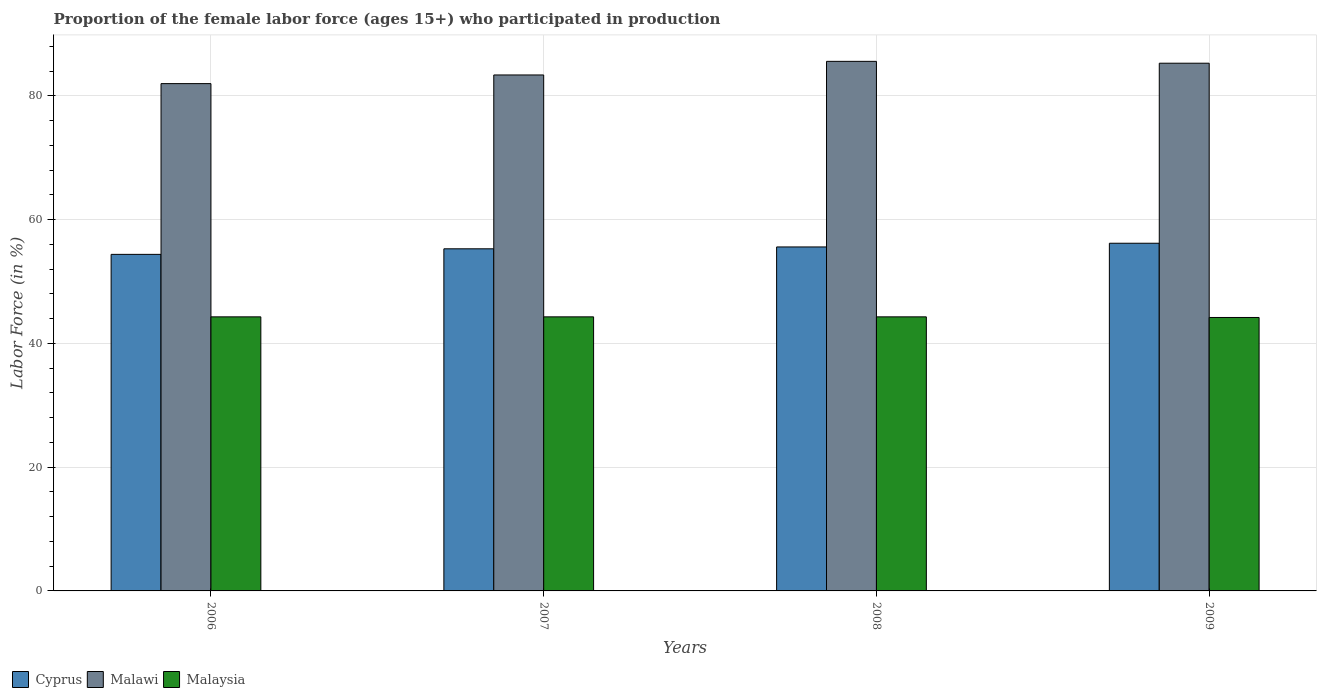How many different coloured bars are there?
Your answer should be very brief. 3. How many bars are there on the 1st tick from the right?
Offer a terse response. 3. In how many cases, is the number of bars for a given year not equal to the number of legend labels?
Keep it short and to the point. 0. What is the proportion of the female labor force who participated in production in Malawi in 2006?
Your answer should be very brief. 82. Across all years, what is the maximum proportion of the female labor force who participated in production in Malaysia?
Offer a very short reply. 44.3. In which year was the proportion of the female labor force who participated in production in Cyprus maximum?
Offer a very short reply. 2009. What is the total proportion of the female labor force who participated in production in Malawi in the graph?
Provide a short and direct response. 336.3. What is the difference between the proportion of the female labor force who participated in production in Malawi in 2006 and that in 2008?
Offer a very short reply. -3.6. What is the difference between the proportion of the female labor force who participated in production in Malaysia in 2008 and the proportion of the female labor force who participated in production in Cyprus in 2006?
Ensure brevity in your answer.  -10.1. What is the average proportion of the female labor force who participated in production in Malaysia per year?
Offer a very short reply. 44.27. In the year 2007, what is the difference between the proportion of the female labor force who participated in production in Malaysia and proportion of the female labor force who participated in production in Malawi?
Offer a terse response. -39.1. In how many years, is the proportion of the female labor force who participated in production in Cyprus greater than 68 %?
Offer a very short reply. 0. What is the ratio of the proportion of the female labor force who participated in production in Malawi in 2007 to that in 2009?
Ensure brevity in your answer.  0.98. Is the difference between the proportion of the female labor force who participated in production in Malaysia in 2008 and 2009 greater than the difference between the proportion of the female labor force who participated in production in Malawi in 2008 and 2009?
Ensure brevity in your answer.  No. What is the difference between the highest and the lowest proportion of the female labor force who participated in production in Malaysia?
Your answer should be very brief. 0.1. In how many years, is the proportion of the female labor force who participated in production in Cyprus greater than the average proportion of the female labor force who participated in production in Cyprus taken over all years?
Provide a short and direct response. 2. What does the 3rd bar from the left in 2009 represents?
Ensure brevity in your answer.  Malaysia. What does the 1st bar from the right in 2006 represents?
Keep it short and to the point. Malaysia. What is the difference between two consecutive major ticks on the Y-axis?
Ensure brevity in your answer.  20. Are the values on the major ticks of Y-axis written in scientific E-notation?
Provide a succinct answer. No. Does the graph contain grids?
Provide a succinct answer. Yes. How are the legend labels stacked?
Provide a succinct answer. Horizontal. What is the title of the graph?
Provide a short and direct response. Proportion of the female labor force (ages 15+) who participated in production. Does "Senegal" appear as one of the legend labels in the graph?
Make the answer very short. No. What is the label or title of the Y-axis?
Give a very brief answer. Labor Force (in %). What is the Labor Force (in %) of Cyprus in 2006?
Give a very brief answer. 54.4. What is the Labor Force (in %) of Malawi in 2006?
Make the answer very short. 82. What is the Labor Force (in %) of Malaysia in 2006?
Your answer should be compact. 44.3. What is the Labor Force (in %) of Cyprus in 2007?
Your answer should be very brief. 55.3. What is the Labor Force (in %) of Malawi in 2007?
Make the answer very short. 83.4. What is the Labor Force (in %) in Malaysia in 2007?
Offer a terse response. 44.3. What is the Labor Force (in %) of Cyprus in 2008?
Your answer should be very brief. 55.6. What is the Labor Force (in %) in Malawi in 2008?
Your response must be concise. 85.6. What is the Labor Force (in %) in Malaysia in 2008?
Your answer should be compact. 44.3. What is the Labor Force (in %) in Cyprus in 2009?
Make the answer very short. 56.2. What is the Labor Force (in %) of Malawi in 2009?
Offer a very short reply. 85.3. What is the Labor Force (in %) in Malaysia in 2009?
Your response must be concise. 44.2. Across all years, what is the maximum Labor Force (in %) in Cyprus?
Offer a terse response. 56.2. Across all years, what is the maximum Labor Force (in %) in Malawi?
Provide a short and direct response. 85.6. Across all years, what is the maximum Labor Force (in %) in Malaysia?
Your answer should be very brief. 44.3. Across all years, what is the minimum Labor Force (in %) of Cyprus?
Provide a short and direct response. 54.4. Across all years, what is the minimum Labor Force (in %) of Malawi?
Your answer should be compact. 82. Across all years, what is the minimum Labor Force (in %) in Malaysia?
Provide a succinct answer. 44.2. What is the total Labor Force (in %) of Cyprus in the graph?
Provide a succinct answer. 221.5. What is the total Labor Force (in %) in Malawi in the graph?
Offer a terse response. 336.3. What is the total Labor Force (in %) in Malaysia in the graph?
Your response must be concise. 177.1. What is the difference between the Labor Force (in %) in Cyprus in 2006 and that in 2007?
Offer a very short reply. -0.9. What is the difference between the Labor Force (in %) of Malaysia in 2006 and that in 2007?
Keep it short and to the point. 0. What is the difference between the Labor Force (in %) in Cyprus in 2006 and that in 2008?
Give a very brief answer. -1.2. What is the difference between the Labor Force (in %) in Malawi in 2006 and that in 2008?
Ensure brevity in your answer.  -3.6. What is the difference between the Labor Force (in %) in Malawi in 2006 and that in 2009?
Make the answer very short. -3.3. What is the difference between the Labor Force (in %) in Cyprus in 2008 and that in 2009?
Provide a short and direct response. -0.6. What is the difference between the Labor Force (in %) in Malawi in 2008 and that in 2009?
Your answer should be compact. 0.3. What is the difference between the Labor Force (in %) of Malawi in 2006 and the Labor Force (in %) of Malaysia in 2007?
Keep it short and to the point. 37.7. What is the difference between the Labor Force (in %) in Cyprus in 2006 and the Labor Force (in %) in Malawi in 2008?
Your answer should be compact. -31.2. What is the difference between the Labor Force (in %) of Cyprus in 2006 and the Labor Force (in %) of Malaysia in 2008?
Keep it short and to the point. 10.1. What is the difference between the Labor Force (in %) of Malawi in 2006 and the Labor Force (in %) of Malaysia in 2008?
Provide a short and direct response. 37.7. What is the difference between the Labor Force (in %) of Cyprus in 2006 and the Labor Force (in %) of Malawi in 2009?
Provide a short and direct response. -30.9. What is the difference between the Labor Force (in %) of Cyprus in 2006 and the Labor Force (in %) of Malaysia in 2009?
Offer a terse response. 10.2. What is the difference between the Labor Force (in %) of Malawi in 2006 and the Labor Force (in %) of Malaysia in 2009?
Give a very brief answer. 37.8. What is the difference between the Labor Force (in %) of Cyprus in 2007 and the Labor Force (in %) of Malawi in 2008?
Offer a terse response. -30.3. What is the difference between the Labor Force (in %) in Cyprus in 2007 and the Labor Force (in %) in Malaysia in 2008?
Make the answer very short. 11. What is the difference between the Labor Force (in %) of Malawi in 2007 and the Labor Force (in %) of Malaysia in 2008?
Offer a very short reply. 39.1. What is the difference between the Labor Force (in %) of Cyprus in 2007 and the Labor Force (in %) of Malawi in 2009?
Your answer should be compact. -30. What is the difference between the Labor Force (in %) in Malawi in 2007 and the Labor Force (in %) in Malaysia in 2009?
Keep it short and to the point. 39.2. What is the difference between the Labor Force (in %) of Cyprus in 2008 and the Labor Force (in %) of Malawi in 2009?
Offer a terse response. -29.7. What is the difference between the Labor Force (in %) in Cyprus in 2008 and the Labor Force (in %) in Malaysia in 2009?
Your answer should be compact. 11.4. What is the difference between the Labor Force (in %) in Malawi in 2008 and the Labor Force (in %) in Malaysia in 2009?
Offer a terse response. 41.4. What is the average Labor Force (in %) of Cyprus per year?
Provide a short and direct response. 55.38. What is the average Labor Force (in %) of Malawi per year?
Offer a very short reply. 84.08. What is the average Labor Force (in %) in Malaysia per year?
Ensure brevity in your answer.  44.27. In the year 2006, what is the difference between the Labor Force (in %) in Cyprus and Labor Force (in %) in Malawi?
Give a very brief answer. -27.6. In the year 2006, what is the difference between the Labor Force (in %) of Cyprus and Labor Force (in %) of Malaysia?
Make the answer very short. 10.1. In the year 2006, what is the difference between the Labor Force (in %) of Malawi and Labor Force (in %) of Malaysia?
Make the answer very short. 37.7. In the year 2007, what is the difference between the Labor Force (in %) in Cyprus and Labor Force (in %) in Malawi?
Your answer should be very brief. -28.1. In the year 2007, what is the difference between the Labor Force (in %) in Malawi and Labor Force (in %) in Malaysia?
Your answer should be very brief. 39.1. In the year 2008, what is the difference between the Labor Force (in %) of Cyprus and Labor Force (in %) of Malawi?
Offer a terse response. -30. In the year 2008, what is the difference between the Labor Force (in %) of Malawi and Labor Force (in %) of Malaysia?
Ensure brevity in your answer.  41.3. In the year 2009, what is the difference between the Labor Force (in %) of Cyprus and Labor Force (in %) of Malawi?
Provide a short and direct response. -29.1. In the year 2009, what is the difference between the Labor Force (in %) in Cyprus and Labor Force (in %) in Malaysia?
Keep it short and to the point. 12. In the year 2009, what is the difference between the Labor Force (in %) of Malawi and Labor Force (in %) of Malaysia?
Offer a very short reply. 41.1. What is the ratio of the Labor Force (in %) in Cyprus in 2006 to that in 2007?
Your response must be concise. 0.98. What is the ratio of the Labor Force (in %) of Malawi in 2006 to that in 2007?
Your response must be concise. 0.98. What is the ratio of the Labor Force (in %) in Malaysia in 2006 to that in 2007?
Your response must be concise. 1. What is the ratio of the Labor Force (in %) of Cyprus in 2006 to that in 2008?
Your answer should be compact. 0.98. What is the ratio of the Labor Force (in %) in Malawi in 2006 to that in 2008?
Provide a succinct answer. 0.96. What is the ratio of the Labor Force (in %) of Malaysia in 2006 to that in 2008?
Offer a terse response. 1. What is the ratio of the Labor Force (in %) in Cyprus in 2006 to that in 2009?
Keep it short and to the point. 0.97. What is the ratio of the Labor Force (in %) in Malawi in 2006 to that in 2009?
Keep it short and to the point. 0.96. What is the ratio of the Labor Force (in %) in Malawi in 2007 to that in 2008?
Offer a terse response. 0.97. What is the ratio of the Labor Force (in %) of Malaysia in 2007 to that in 2008?
Offer a very short reply. 1. What is the ratio of the Labor Force (in %) in Cyprus in 2007 to that in 2009?
Keep it short and to the point. 0.98. What is the ratio of the Labor Force (in %) of Malawi in 2007 to that in 2009?
Offer a terse response. 0.98. What is the ratio of the Labor Force (in %) of Malaysia in 2007 to that in 2009?
Offer a terse response. 1. What is the ratio of the Labor Force (in %) of Cyprus in 2008 to that in 2009?
Make the answer very short. 0.99. What is the ratio of the Labor Force (in %) of Malawi in 2008 to that in 2009?
Make the answer very short. 1. What is the difference between the highest and the second highest Labor Force (in %) in Cyprus?
Give a very brief answer. 0.6. 